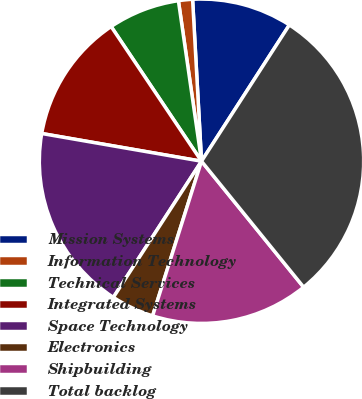Convert chart. <chart><loc_0><loc_0><loc_500><loc_500><pie_chart><fcel>Mission Systems<fcel>Information Technology<fcel>Technical Services<fcel>Integrated Systems<fcel>Space Technology<fcel>Electronics<fcel>Shipbuilding<fcel>Total backlog<nl><fcel>9.99%<fcel>1.4%<fcel>7.13%<fcel>12.86%<fcel>18.59%<fcel>4.27%<fcel>15.72%<fcel>30.04%<nl></chart> 